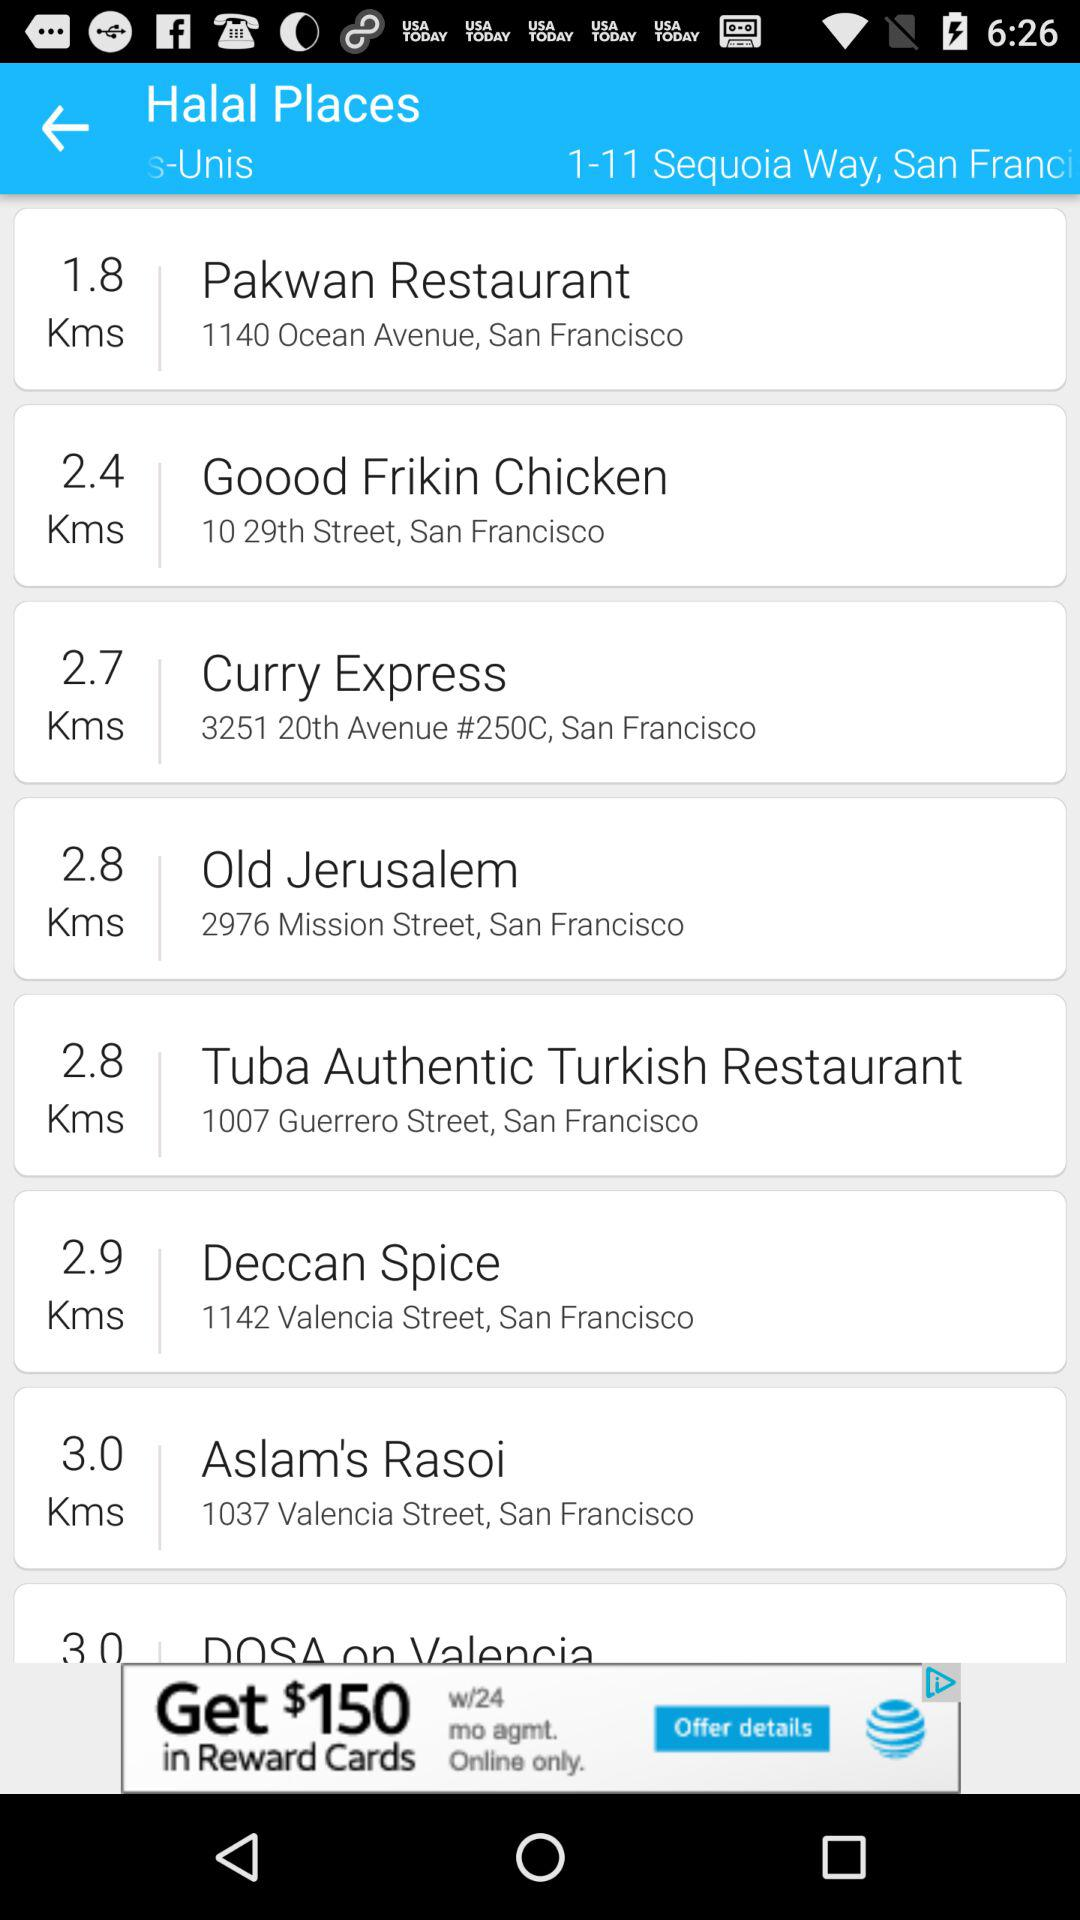How much is the distance to "Pakwan Restaurant"? The distance is 1.8 kilometers. 